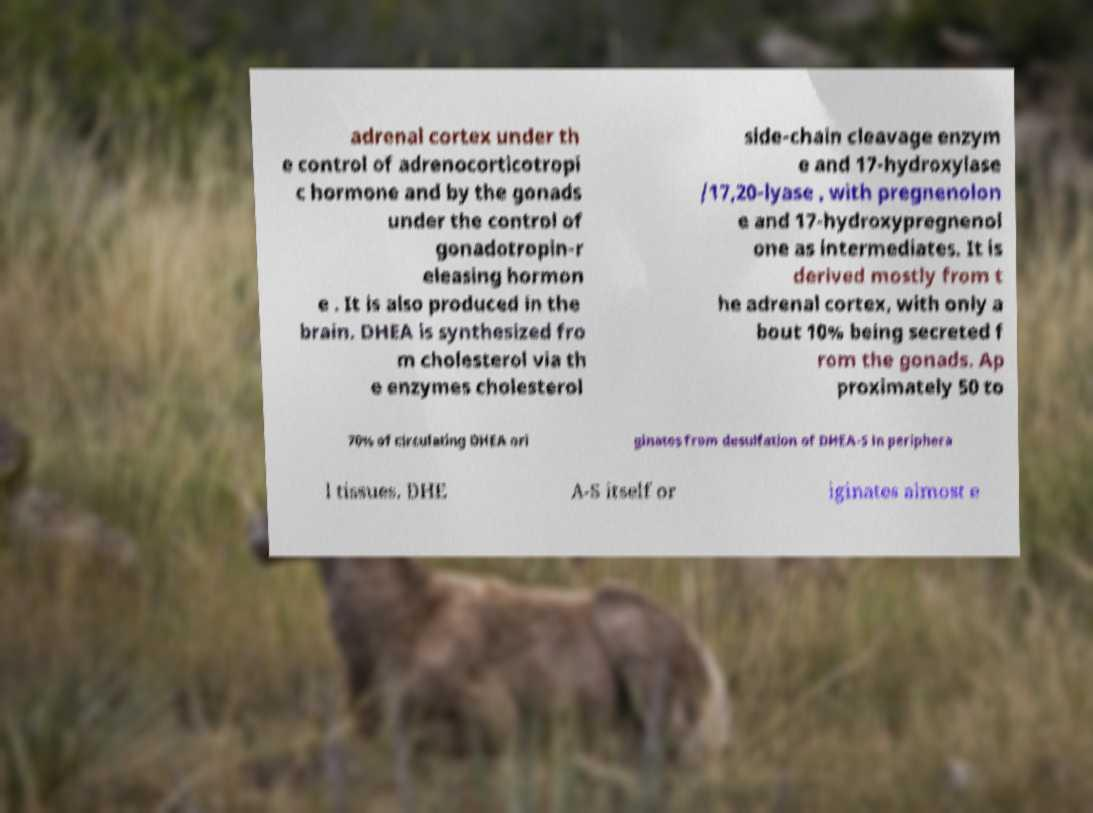Could you extract and type out the text from this image? adrenal cortex under th e control of adrenocorticotropi c hormone and by the gonads under the control of gonadotropin-r eleasing hormon e . It is also produced in the brain. DHEA is synthesized fro m cholesterol via th e enzymes cholesterol side-chain cleavage enzym e and 17-hydroxylase /17,20-lyase , with pregnenolon e and 17-hydroxypregnenol one as intermediates. It is derived mostly from t he adrenal cortex, with only a bout 10% being secreted f rom the gonads. Ap proximately 50 to 70% of circulating DHEA ori ginates from desulfation of DHEA-S in periphera l tissues. DHE A-S itself or iginates almost e 